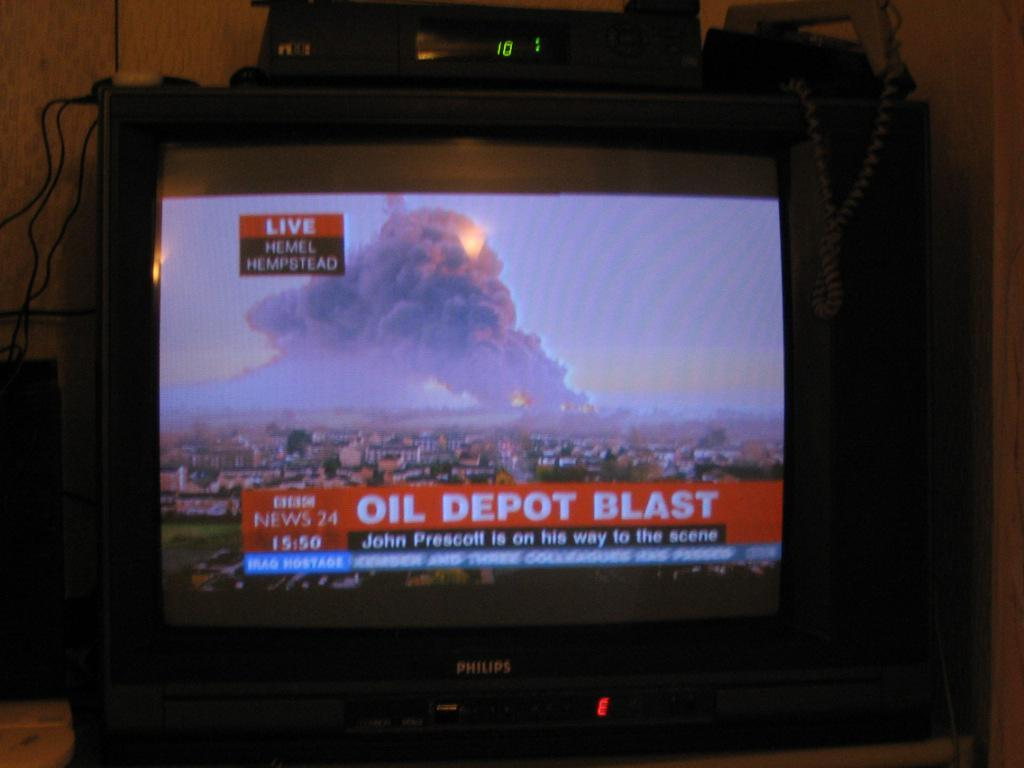<image>
Create a compact narrative representing the image presented. A Philips television screen with BBC news turned on. 